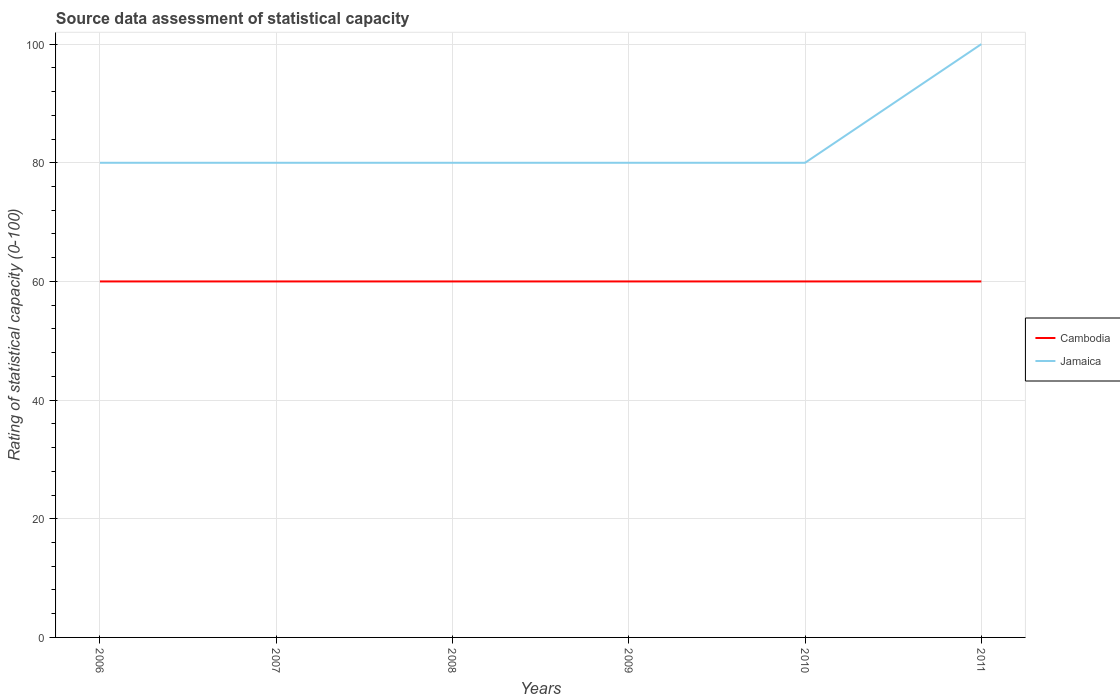Across all years, what is the maximum rating of statistical capacity in Cambodia?
Your response must be concise. 60. What is the difference between the highest and the second highest rating of statistical capacity in Jamaica?
Make the answer very short. 20. How many years are there in the graph?
Your answer should be compact. 6. Does the graph contain grids?
Keep it short and to the point. Yes. Where does the legend appear in the graph?
Your answer should be very brief. Center right. How many legend labels are there?
Your response must be concise. 2. How are the legend labels stacked?
Give a very brief answer. Vertical. What is the title of the graph?
Your response must be concise. Source data assessment of statistical capacity. What is the label or title of the Y-axis?
Provide a succinct answer. Rating of statistical capacity (0-100). What is the Rating of statistical capacity (0-100) in Cambodia in 2006?
Provide a short and direct response. 60. What is the Rating of statistical capacity (0-100) of Cambodia in 2007?
Your answer should be compact. 60. What is the Rating of statistical capacity (0-100) of Jamaica in 2007?
Your answer should be compact. 80. What is the Rating of statistical capacity (0-100) in Cambodia in 2008?
Make the answer very short. 60. What is the Rating of statistical capacity (0-100) of Jamaica in 2008?
Give a very brief answer. 80. What is the Rating of statistical capacity (0-100) of Cambodia in 2009?
Make the answer very short. 60. What is the Rating of statistical capacity (0-100) of Jamaica in 2009?
Offer a very short reply. 80. What is the Rating of statistical capacity (0-100) of Cambodia in 2010?
Provide a succinct answer. 60. What is the Rating of statistical capacity (0-100) in Cambodia in 2011?
Keep it short and to the point. 60. Across all years, what is the maximum Rating of statistical capacity (0-100) in Cambodia?
Give a very brief answer. 60. Across all years, what is the minimum Rating of statistical capacity (0-100) of Cambodia?
Keep it short and to the point. 60. What is the total Rating of statistical capacity (0-100) of Cambodia in the graph?
Offer a very short reply. 360. What is the difference between the Rating of statistical capacity (0-100) of Cambodia in 2006 and that in 2007?
Make the answer very short. 0. What is the difference between the Rating of statistical capacity (0-100) of Jamaica in 2006 and that in 2008?
Keep it short and to the point. 0. What is the difference between the Rating of statistical capacity (0-100) in Cambodia in 2006 and that in 2009?
Give a very brief answer. 0. What is the difference between the Rating of statistical capacity (0-100) of Cambodia in 2006 and that in 2010?
Give a very brief answer. 0. What is the difference between the Rating of statistical capacity (0-100) of Jamaica in 2006 and that in 2011?
Ensure brevity in your answer.  -20. What is the difference between the Rating of statistical capacity (0-100) of Cambodia in 2007 and that in 2008?
Make the answer very short. 0. What is the difference between the Rating of statistical capacity (0-100) in Jamaica in 2007 and that in 2008?
Your answer should be very brief. 0. What is the difference between the Rating of statistical capacity (0-100) in Cambodia in 2007 and that in 2009?
Offer a very short reply. 0. What is the difference between the Rating of statistical capacity (0-100) in Cambodia in 2007 and that in 2010?
Your answer should be compact. 0. What is the difference between the Rating of statistical capacity (0-100) in Cambodia in 2007 and that in 2011?
Make the answer very short. 0. What is the difference between the Rating of statistical capacity (0-100) in Jamaica in 2007 and that in 2011?
Provide a short and direct response. -20. What is the difference between the Rating of statistical capacity (0-100) in Cambodia in 2008 and that in 2009?
Your response must be concise. 0. What is the difference between the Rating of statistical capacity (0-100) in Jamaica in 2008 and that in 2011?
Provide a short and direct response. -20. What is the difference between the Rating of statistical capacity (0-100) of Cambodia in 2009 and that in 2010?
Ensure brevity in your answer.  0. What is the difference between the Rating of statistical capacity (0-100) in Jamaica in 2009 and that in 2011?
Provide a short and direct response. -20. What is the difference between the Rating of statistical capacity (0-100) in Cambodia in 2010 and that in 2011?
Give a very brief answer. 0. What is the difference between the Rating of statistical capacity (0-100) of Jamaica in 2010 and that in 2011?
Ensure brevity in your answer.  -20. What is the difference between the Rating of statistical capacity (0-100) of Cambodia in 2006 and the Rating of statistical capacity (0-100) of Jamaica in 2010?
Your answer should be very brief. -20. What is the difference between the Rating of statistical capacity (0-100) of Cambodia in 2007 and the Rating of statistical capacity (0-100) of Jamaica in 2009?
Offer a very short reply. -20. What is the difference between the Rating of statistical capacity (0-100) in Cambodia in 2007 and the Rating of statistical capacity (0-100) in Jamaica in 2011?
Offer a very short reply. -40. What is the difference between the Rating of statistical capacity (0-100) of Cambodia in 2008 and the Rating of statistical capacity (0-100) of Jamaica in 2010?
Offer a terse response. -20. What is the difference between the Rating of statistical capacity (0-100) in Cambodia in 2009 and the Rating of statistical capacity (0-100) in Jamaica in 2010?
Provide a succinct answer. -20. What is the average Rating of statistical capacity (0-100) of Jamaica per year?
Your response must be concise. 83.33. In the year 2006, what is the difference between the Rating of statistical capacity (0-100) in Cambodia and Rating of statistical capacity (0-100) in Jamaica?
Offer a very short reply. -20. In the year 2008, what is the difference between the Rating of statistical capacity (0-100) in Cambodia and Rating of statistical capacity (0-100) in Jamaica?
Give a very brief answer. -20. In the year 2009, what is the difference between the Rating of statistical capacity (0-100) in Cambodia and Rating of statistical capacity (0-100) in Jamaica?
Provide a succinct answer. -20. In the year 2011, what is the difference between the Rating of statistical capacity (0-100) in Cambodia and Rating of statistical capacity (0-100) in Jamaica?
Your answer should be compact. -40. What is the ratio of the Rating of statistical capacity (0-100) of Jamaica in 2006 to that in 2007?
Keep it short and to the point. 1. What is the ratio of the Rating of statistical capacity (0-100) in Jamaica in 2006 to that in 2008?
Offer a terse response. 1. What is the ratio of the Rating of statistical capacity (0-100) of Cambodia in 2006 to that in 2009?
Provide a short and direct response. 1. What is the ratio of the Rating of statistical capacity (0-100) in Jamaica in 2006 to that in 2009?
Provide a succinct answer. 1. What is the ratio of the Rating of statistical capacity (0-100) of Cambodia in 2006 to that in 2010?
Give a very brief answer. 1. What is the ratio of the Rating of statistical capacity (0-100) of Jamaica in 2006 to that in 2010?
Make the answer very short. 1. What is the ratio of the Rating of statistical capacity (0-100) in Jamaica in 2006 to that in 2011?
Provide a short and direct response. 0.8. What is the ratio of the Rating of statistical capacity (0-100) in Jamaica in 2007 to that in 2008?
Give a very brief answer. 1. What is the ratio of the Rating of statistical capacity (0-100) in Jamaica in 2007 to that in 2009?
Provide a succinct answer. 1. What is the ratio of the Rating of statistical capacity (0-100) in Cambodia in 2007 to that in 2011?
Your response must be concise. 1. What is the ratio of the Rating of statistical capacity (0-100) in Cambodia in 2008 to that in 2011?
Your answer should be very brief. 1. What is the ratio of the Rating of statistical capacity (0-100) in Jamaica in 2008 to that in 2011?
Ensure brevity in your answer.  0.8. What is the ratio of the Rating of statistical capacity (0-100) of Cambodia in 2009 to that in 2010?
Give a very brief answer. 1. What is the ratio of the Rating of statistical capacity (0-100) of Jamaica in 2009 to that in 2010?
Give a very brief answer. 1. What is the ratio of the Rating of statistical capacity (0-100) of Jamaica in 2009 to that in 2011?
Your answer should be compact. 0.8. What is the ratio of the Rating of statistical capacity (0-100) of Jamaica in 2010 to that in 2011?
Your response must be concise. 0.8. What is the difference between the highest and the second highest Rating of statistical capacity (0-100) in Jamaica?
Keep it short and to the point. 20. What is the difference between the highest and the lowest Rating of statistical capacity (0-100) of Jamaica?
Provide a short and direct response. 20. 